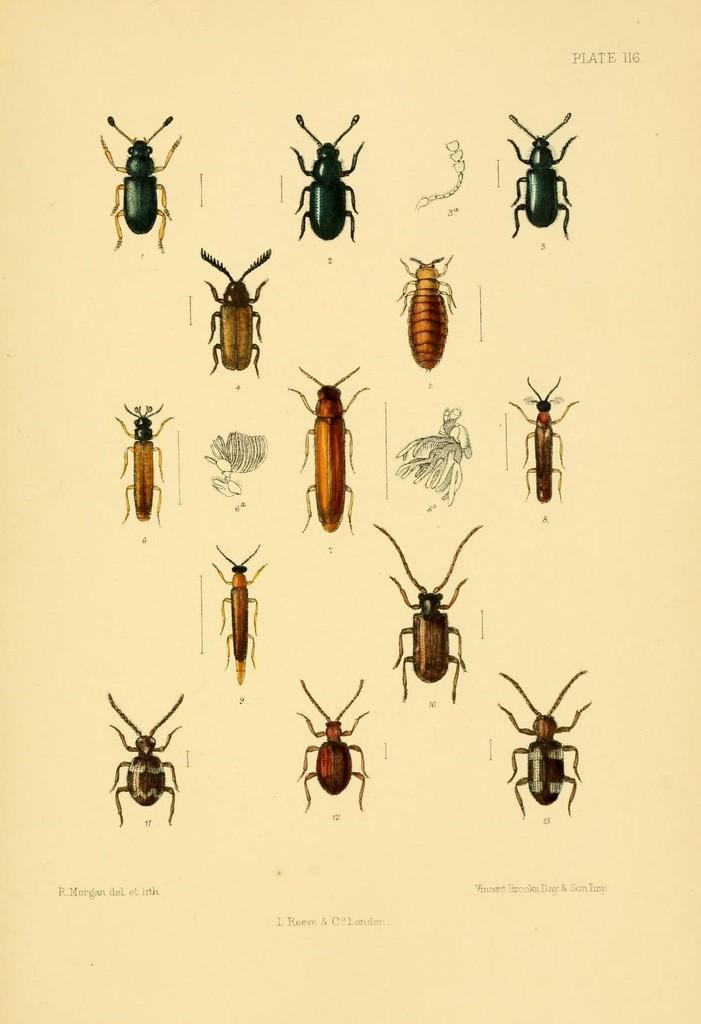What type of creatures are depicted in the images in the picture? There are pictures of insects in the image. What else can be seen in the image besides the insect pictures? There is text on a paper in the image. Where is the vase located in the image? There is no vase present in the image. What type of food is being prepared in the image? There is no food preparation visible in the image; it only contains pictures of insects and text on a paper. 